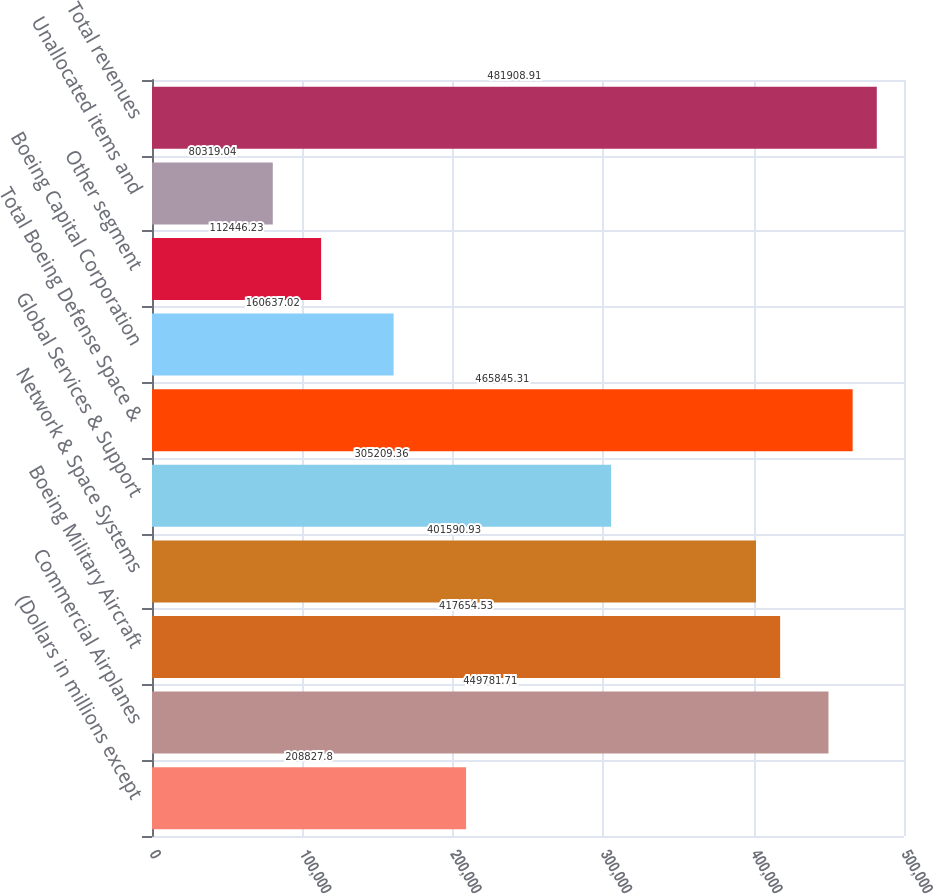Convert chart to OTSL. <chart><loc_0><loc_0><loc_500><loc_500><bar_chart><fcel>(Dollars in millions except<fcel>Commercial Airplanes<fcel>Boeing Military Aircraft<fcel>Network & Space Systems<fcel>Global Services & Support<fcel>Total Boeing Defense Space &<fcel>Boeing Capital Corporation<fcel>Other segment<fcel>Unallocated items and<fcel>Total revenues<nl><fcel>208828<fcel>449782<fcel>417655<fcel>401591<fcel>305209<fcel>465845<fcel>160637<fcel>112446<fcel>80319<fcel>481909<nl></chart> 